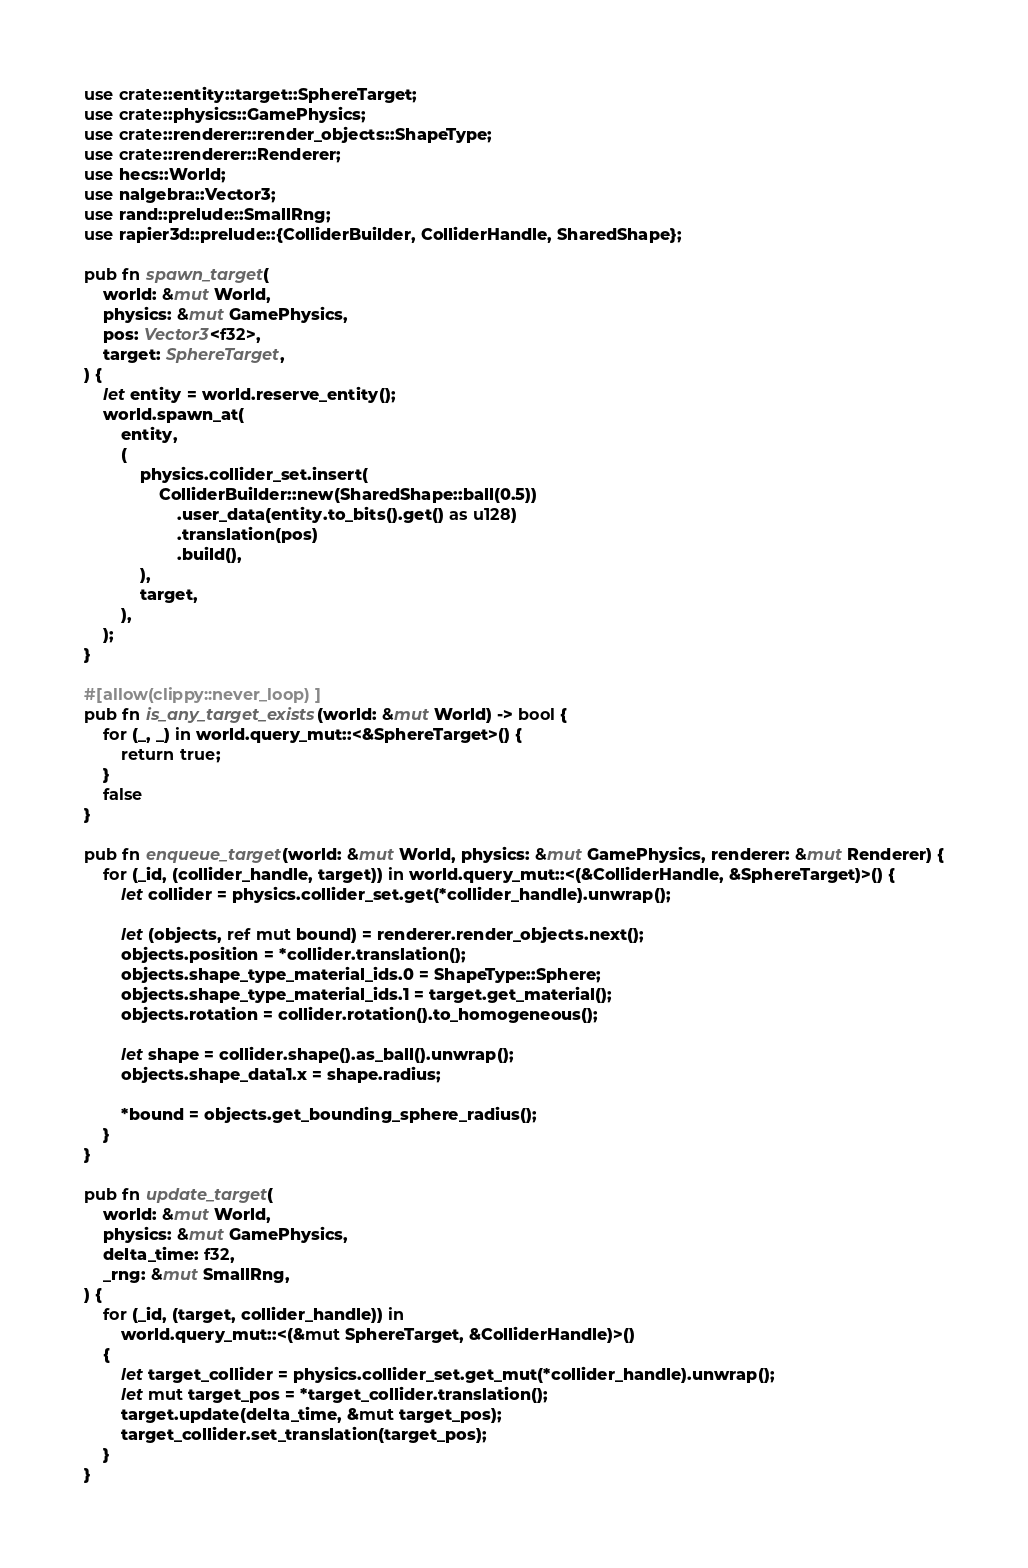Convert code to text. <code><loc_0><loc_0><loc_500><loc_500><_Rust_>use crate::entity::target::SphereTarget;
use crate::physics::GamePhysics;
use crate::renderer::render_objects::ShapeType;
use crate::renderer::Renderer;
use hecs::World;
use nalgebra::Vector3;
use rand::prelude::SmallRng;
use rapier3d::prelude::{ColliderBuilder, ColliderHandle, SharedShape};

pub fn spawn_target(
    world: &mut World,
    physics: &mut GamePhysics,
    pos: Vector3<f32>,
    target: SphereTarget,
) {
    let entity = world.reserve_entity();
    world.spawn_at(
        entity,
        (
            physics.collider_set.insert(
                ColliderBuilder::new(SharedShape::ball(0.5))
                    .user_data(entity.to_bits().get() as u128)
                    .translation(pos)
                    .build(),
            ),
            target,
        ),
    );
}

#[allow(clippy::never_loop)]
pub fn is_any_target_exists(world: &mut World) -> bool {
    for (_, _) in world.query_mut::<&SphereTarget>() {
        return true;
    }
    false
}

pub fn enqueue_target(world: &mut World, physics: &mut GamePhysics, renderer: &mut Renderer) {
    for (_id, (collider_handle, target)) in world.query_mut::<(&ColliderHandle, &SphereTarget)>() {
        let collider = physics.collider_set.get(*collider_handle).unwrap();

        let (objects, ref mut bound) = renderer.render_objects.next();
        objects.position = *collider.translation();
        objects.shape_type_material_ids.0 = ShapeType::Sphere;
        objects.shape_type_material_ids.1 = target.get_material();
        objects.rotation = collider.rotation().to_homogeneous();

        let shape = collider.shape().as_ball().unwrap();
        objects.shape_data1.x = shape.radius;

        *bound = objects.get_bounding_sphere_radius();
    }
}

pub fn update_target(
    world: &mut World,
    physics: &mut GamePhysics,
    delta_time: f32,
    _rng: &mut SmallRng,
) {
    for (_id, (target, collider_handle)) in
        world.query_mut::<(&mut SphereTarget, &ColliderHandle)>()
    {
        let target_collider = physics.collider_set.get_mut(*collider_handle).unwrap();
        let mut target_pos = *target_collider.translation();
        target.update(delta_time, &mut target_pos);
        target_collider.set_translation(target_pos);
    }
}
</code> 